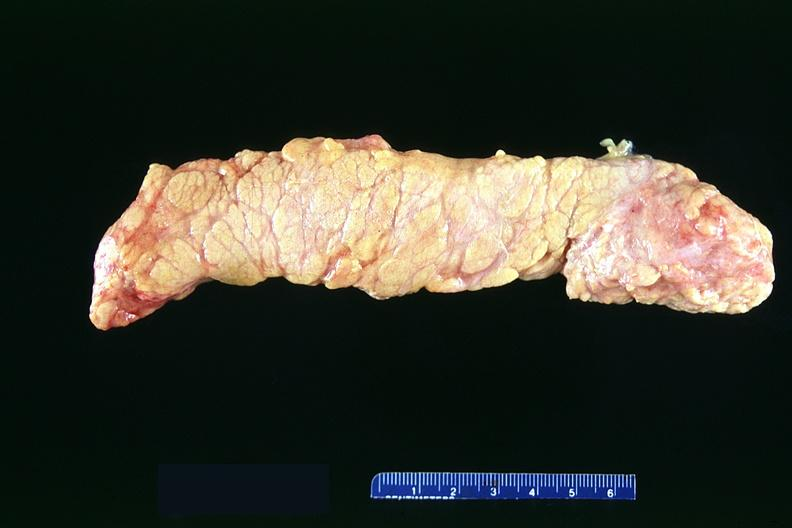what does this image show?
Answer the question using a single word or phrase. Normal pancreas 